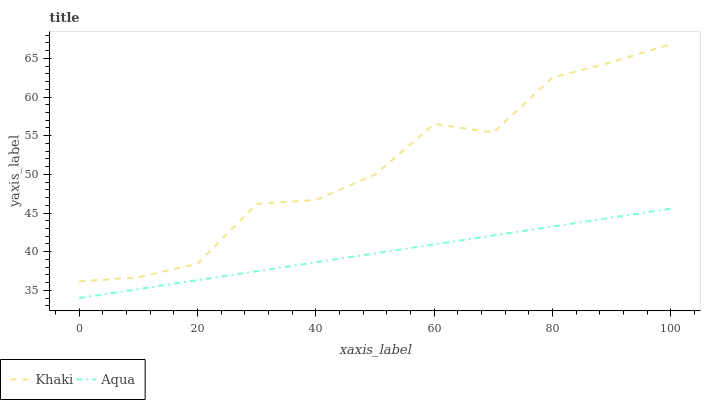Does Aqua have the maximum area under the curve?
Answer yes or no. No. Is Aqua the roughest?
Answer yes or no. No. Does Aqua have the highest value?
Answer yes or no. No. Is Aqua less than Khaki?
Answer yes or no. Yes. Is Khaki greater than Aqua?
Answer yes or no. Yes. Does Aqua intersect Khaki?
Answer yes or no. No. 